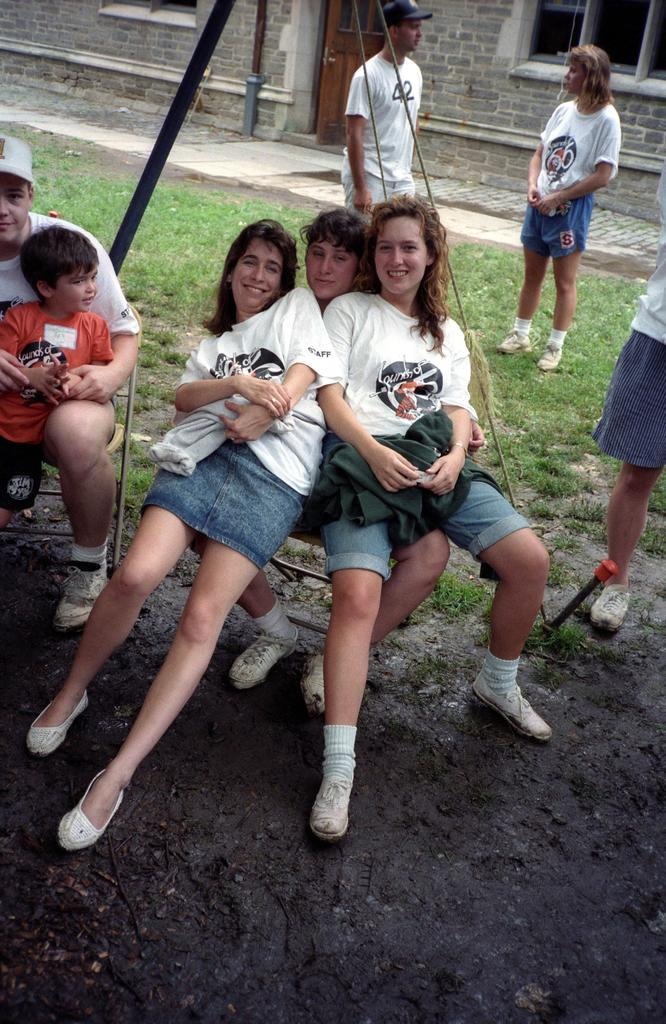What are the persons in the image doing? The persons in the image are sitting on chairs or standing on the ground. What can be seen in the background of the image? There are walls, windows, and a door visible in the background of the image. What type of art is being created with the mitten in the image? There is no mitten present in the image, and therefore no such activity can be observed. 